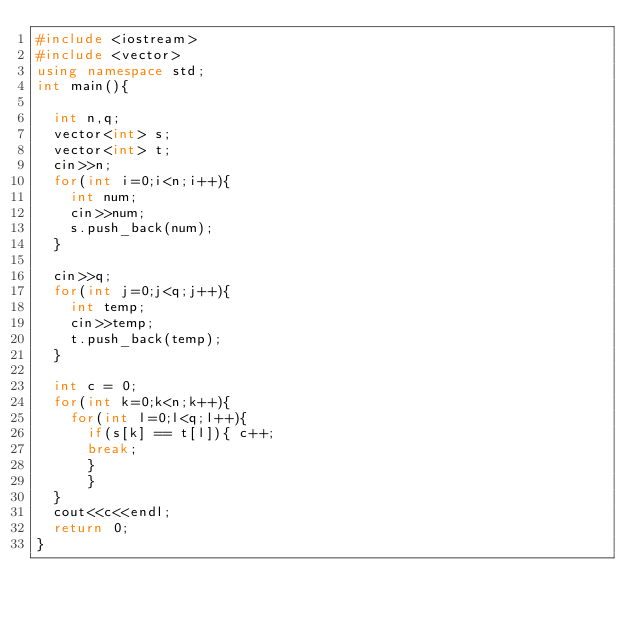<code> <loc_0><loc_0><loc_500><loc_500><_C++_>#include <iostream>
#include <vector>
using namespace std;
int main(){

	int n,q;
	vector<int> s;
	vector<int> t;
	cin>>n;
	for(int i=0;i<n;i++){
		int num;
		cin>>num;
		s.push_back(num);
	}

	cin>>q;
	for(int j=0;j<q;j++){
		int temp;
		cin>>temp;
		t.push_back(temp);
	}
	
	int c = 0;
	for(int k=0;k<n;k++){
		for(int l=0;l<q;l++){
			if(s[k] == t[l]){ c++;
			break;	
			}
			}
	}
	cout<<c<<endl;
	return 0;
}</code> 